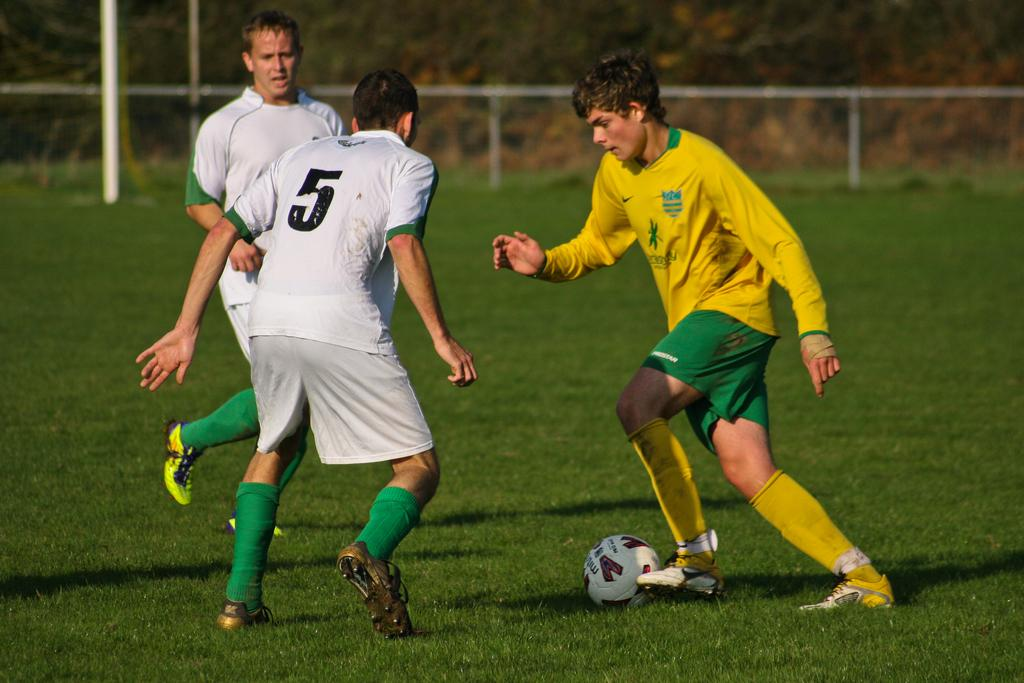What is the man in the image wearing? The man is wearing a yellow jersey in the image. What is the man doing with the football? The man is hitting a football in the image. How many other persons are in the image, and what are they wearing? There are two other persons in the image, and they are wearing white jerseys. What are the positions of these two persons in the image? These two persons are standing in the image. What can be seen in the background of the image? In the background of the image, there are metal poles, grass, and trees. What type of jeans is the man wearing in the image? The man is not wearing jeans in the image; he is wearing a yellow jersey. What kind of lunch is being prepared in the image? There is no mention of lunch or any food preparation in the image. 